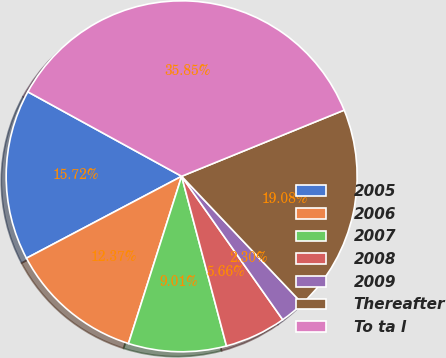<chart> <loc_0><loc_0><loc_500><loc_500><pie_chart><fcel>2005<fcel>2006<fcel>2007<fcel>2008<fcel>2009<fcel>Thereafter<fcel>To ta l<nl><fcel>15.72%<fcel>12.37%<fcel>9.01%<fcel>5.66%<fcel>2.3%<fcel>19.08%<fcel>35.85%<nl></chart> 